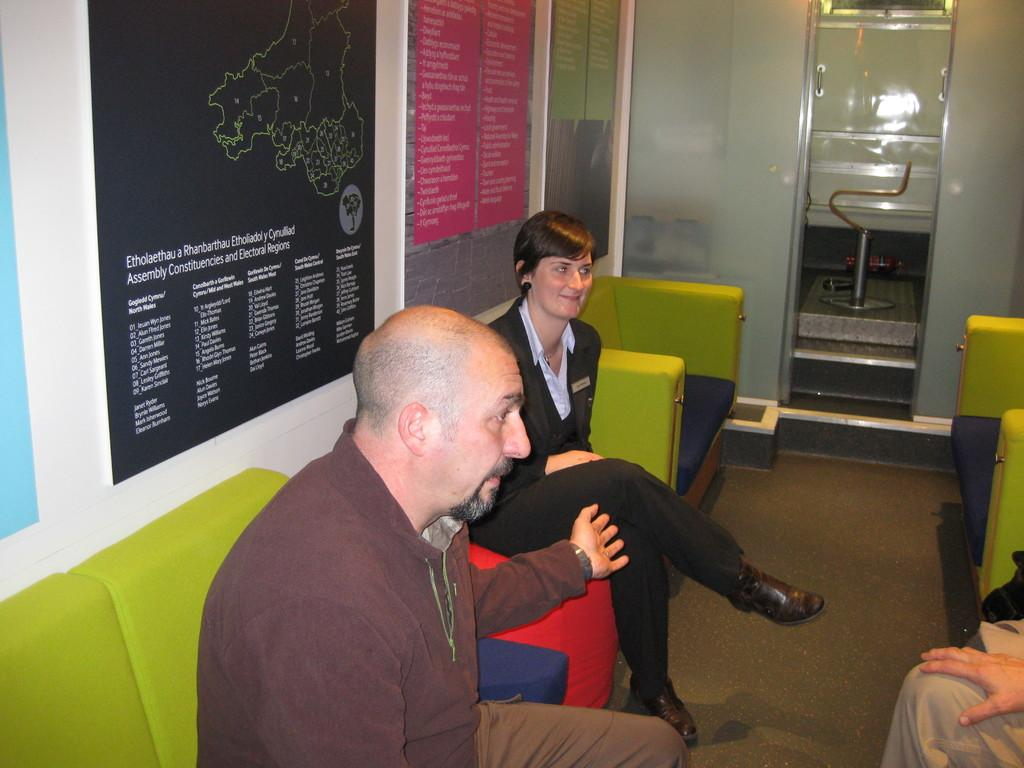<image>
Share a concise interpretation of the image provided. People talk to one another next to a map that states Etholaethau a Rhanbarthau Etholiadol y Cynulliad Assembly Constituencies and Electoral Regions 